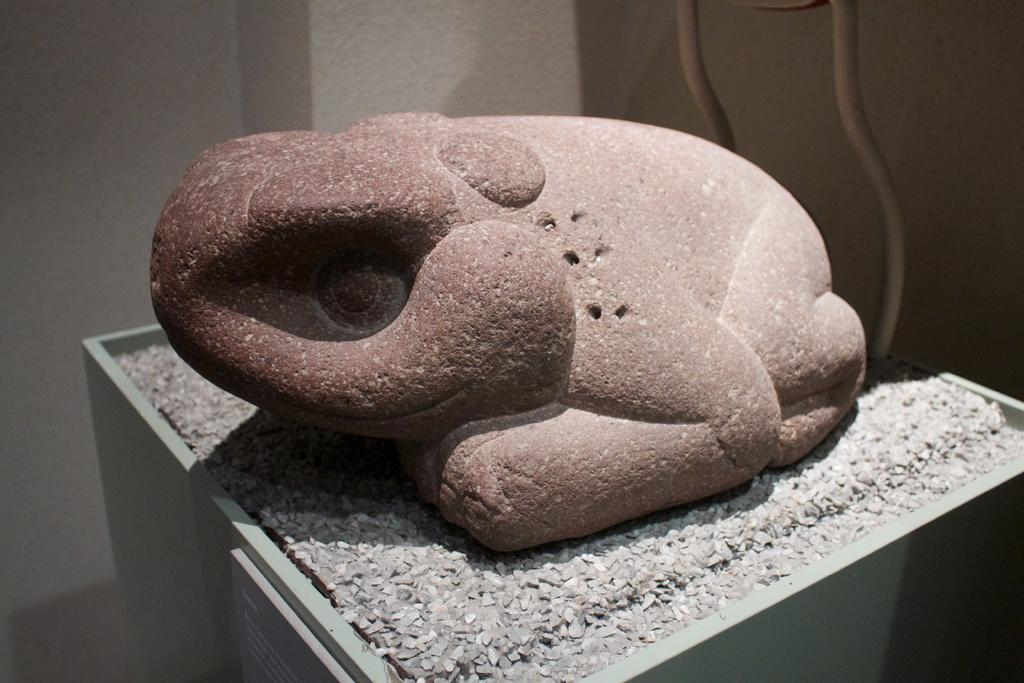What type of artwork is depicted in the image? There is a stone carving in the image. What else can be seen in the image besides the stone carving? There is a board with text in the image. Are there any objects near the wall in the image? Yes, there are two objects near the wall in the image. How many planes are flying in the image? There are no planes visible in the image. What idea does the stone carving represent? The stone carving does not represent an idea; it is a piece of artwork. 